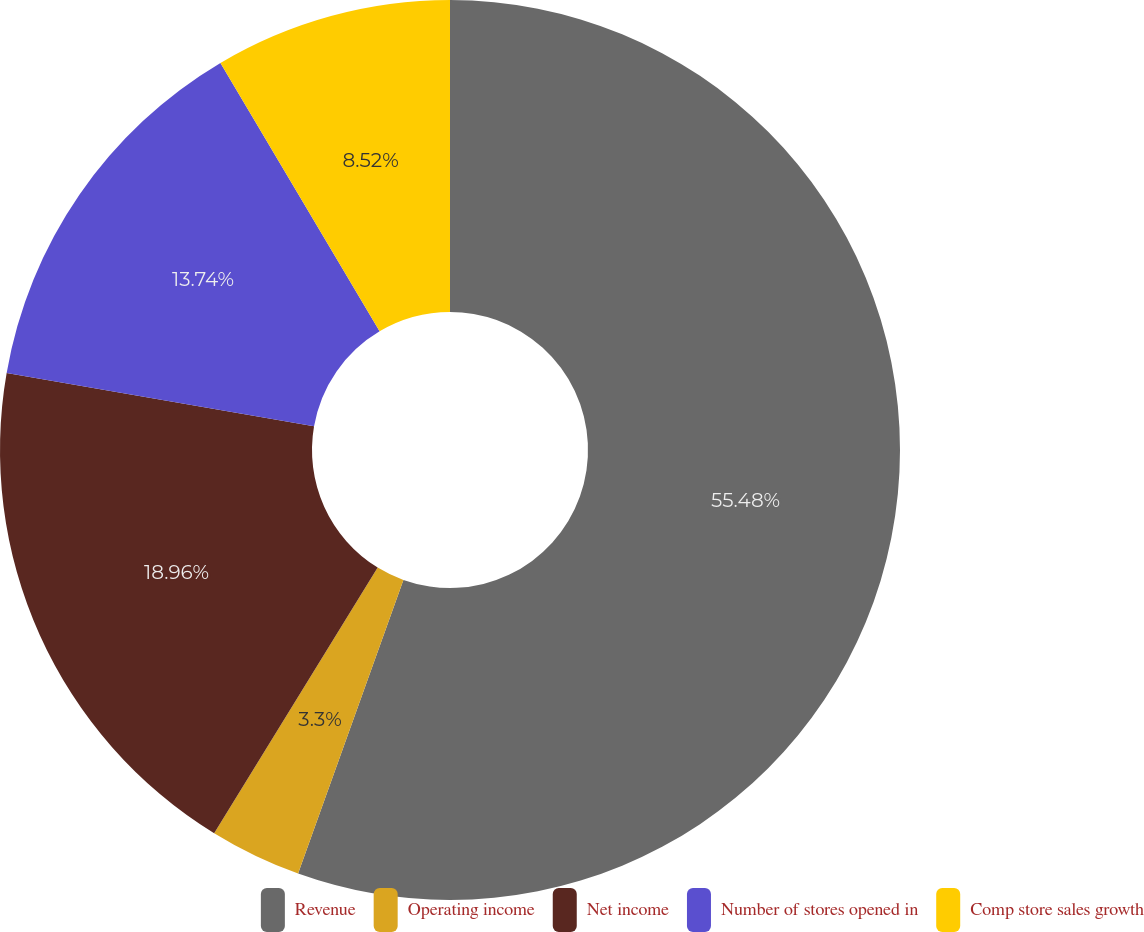Convert chart. <chart><loc_0><loc_0><loc_500><loc_500><pie_chart><fcel>Revenue<fcel>Operating income<fcel>Net income<fcel>Number of stores opened in<fcel>Comp store sales growth<nl><fcel>55.48%<fcel>3.3%<fcel>18.96%<fcel>13.74%<fcel>8.52%<nl></chart> 